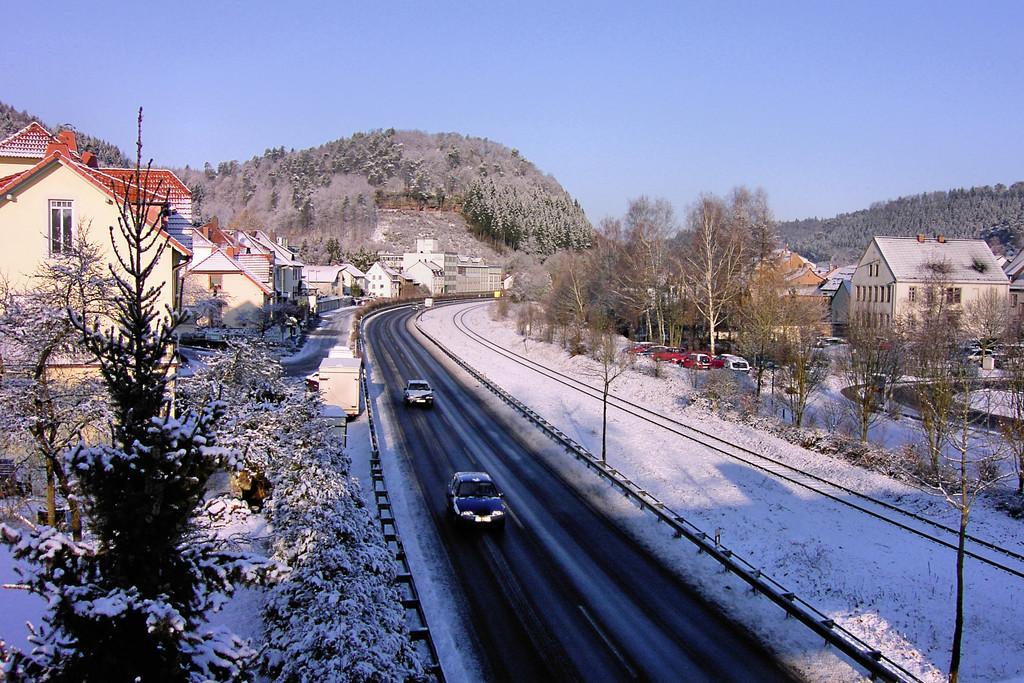Can you describe this image briefly? In this image I can see a road, on the road I can see vehicles and I can see houses and trees vehicles visible on the left side and on the right side and in the middle I can see the hill at the top I can see the sky and I can see snowfall on tree sand road visible in the middle. 